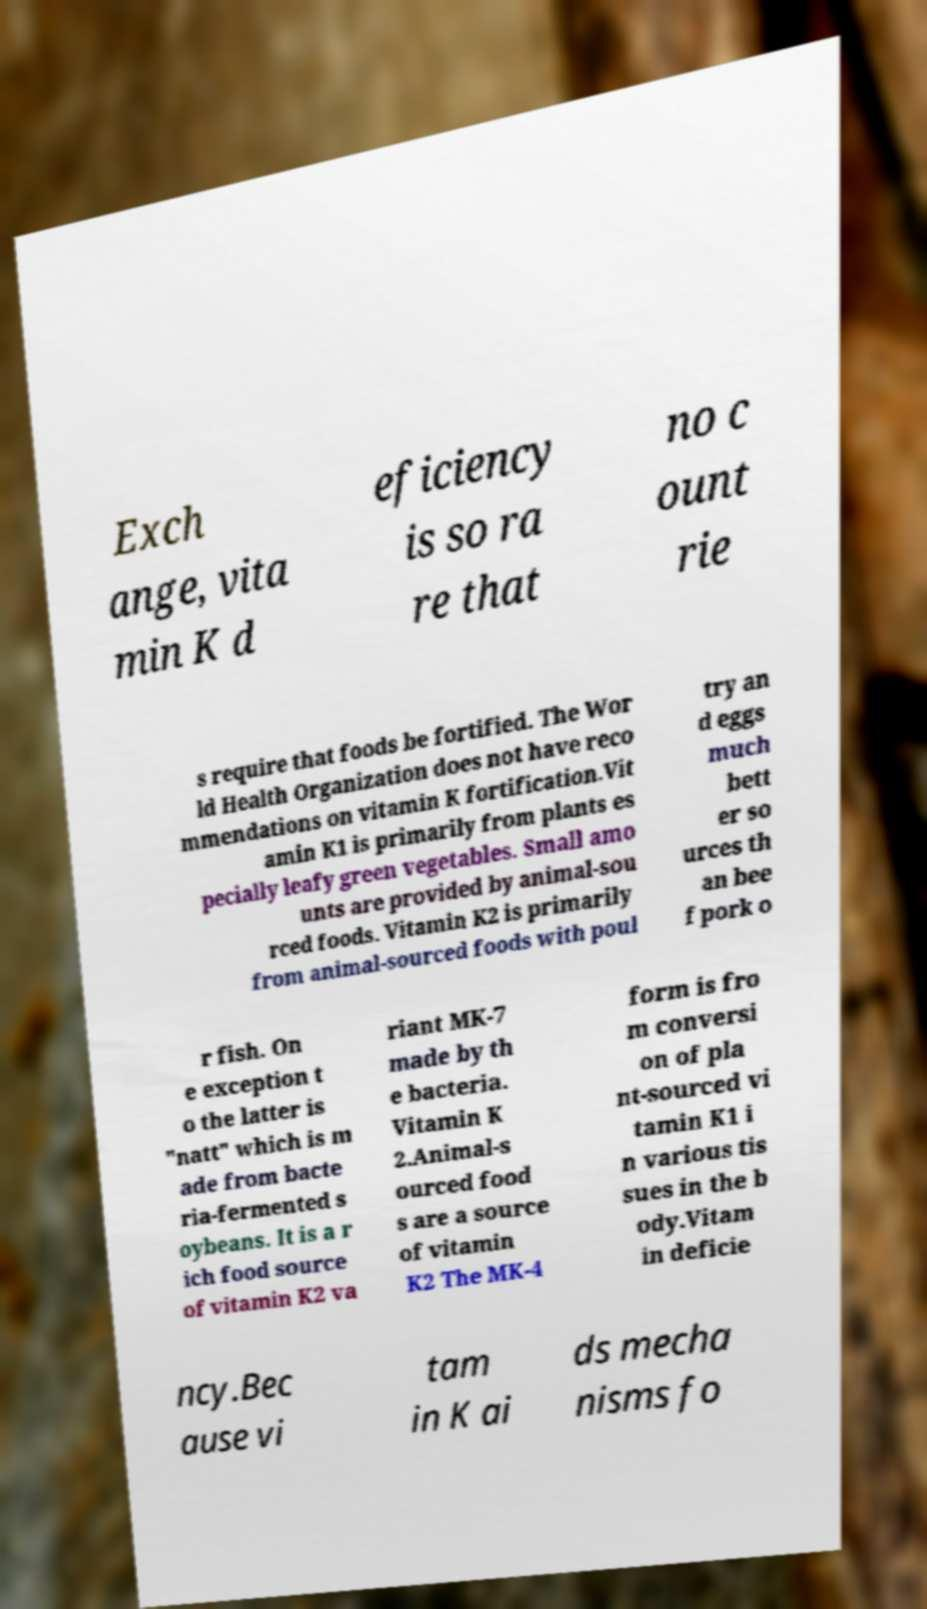Please identify and transcribe the text found in this image. Exch ange, vita min K d eficiency is so ra re that no c ount rie s require that foods be fortified. The Wor ld Health Organization does not have reco mmendations on vitamin K fortification.Vit amin K1 is primarily from plants es pecially leafy green vegetables. Small amo unts are provided by animal-sou rced foods. Vitamin K2 is primarily from animal-sourced foods with poul try an d eggs much bett er so urces th an bee f pork o r fish. On e exception t o the latter is "natt" which is m ade from bacte ria-fermented s oybeans. It is a r ich food source of vitamin K2 va riant MK-7 made by th e bacteria. Vitamin K 2.Animal-s ourced food s are a source of vitamin K2 The MK-4 form is fro m conversi on of pla nt-sourced vi tamin K1 i n various tis sues in the b ody.Vitam in deficie ncy.Bec ause vi tam in K ai ds mecha nisms fo 